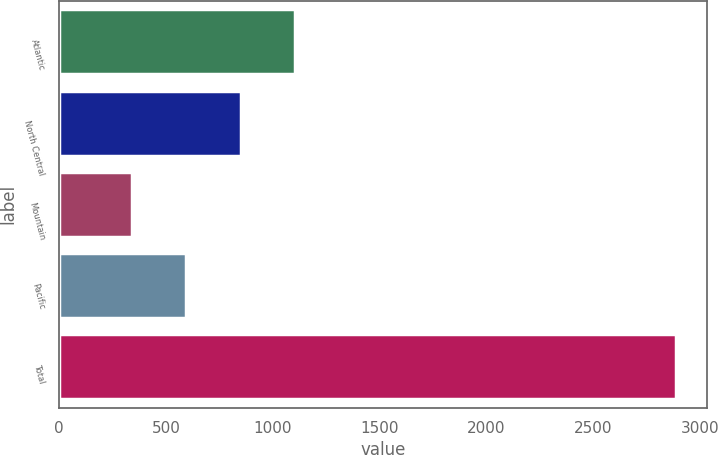<chart> <loc_0><loc_0><loc_500><loc_500><bar_chart><fcel>Atlantic<fcel>North Central<fcel>Mountain<fcel>Pacific<fcel>Total<nl><fcel>1104.1<fcel>849.4<fcel>340<fcel>594.7<fcel>2887<nl></chart> 